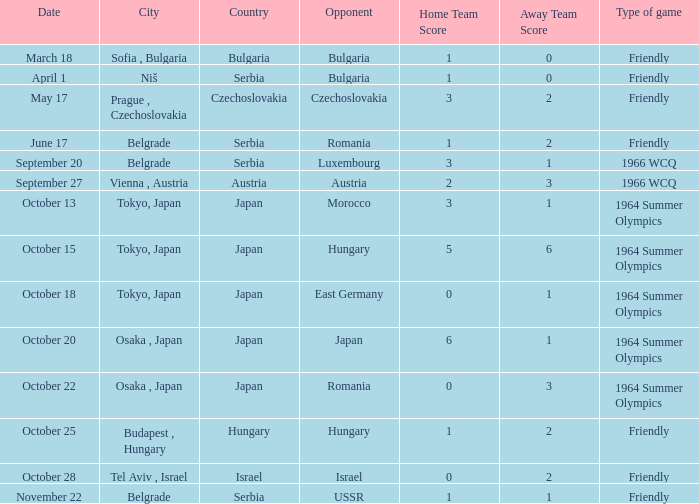What was the opponent on october 28? Israel. 